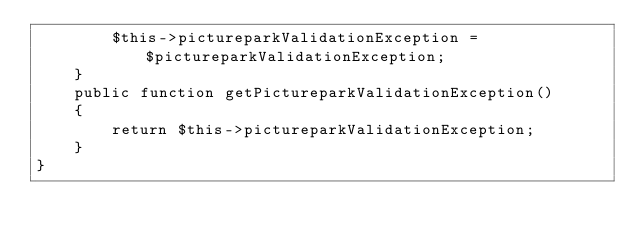Convert code to text. <code><loc_0><loc_0><loc_500><loc_500><_PHP_>        $this->pictureparkValidationException = $pictureparkValidationException;
    }
    public function getPictureparkValidationException()
    {
        return $this->pictureparkValidationException;
    }
}</code> 